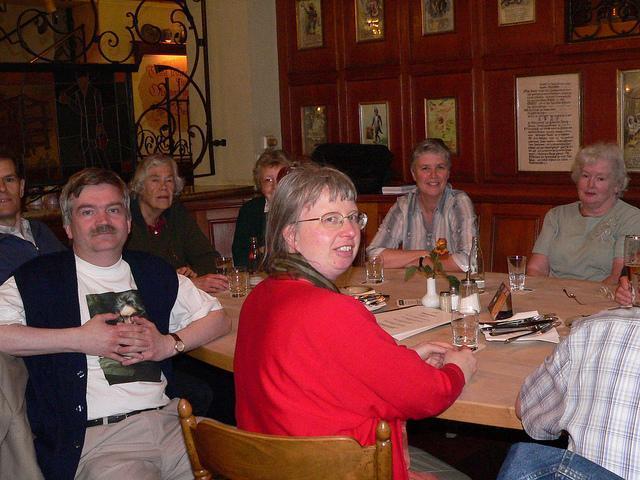How many people are wearing glasses?
Give a very brief answer. 2. How many men are sitting at the table?
Give a very brief answer. 3. How many people are there?
Give a very brief answer. 8. 